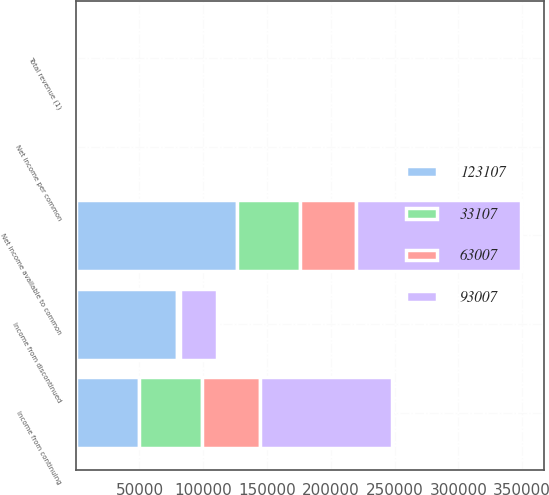Convert chart to OTSL. <chart><loc_0><loc_0><loc_500><loc_500><stacked_bar_chart><ecel><fcel>Total revenue (1)<fcel>Income from continuing<fcel>Income from discontinued<fcel>Net income available to common<fcel>Net income per common<nl><fcel>63007<fcel>1.62<fcel>45383<fcel>1137<fcel>44345<fcel>1.45<nl><fcel>33107<fcel>1.62<fcel>49319<fcel>1733<fcel>48877<fcel>0.86<nl><fcel>123107<fcel>1.62<fcel>49677<fcel>79092<fcel>126594<fcel>0.53<nl><fcel>93007<fcel>1.62<fcel>103289<fcel>28530<fcel>129644<fcel>0.58<nl></chart> 